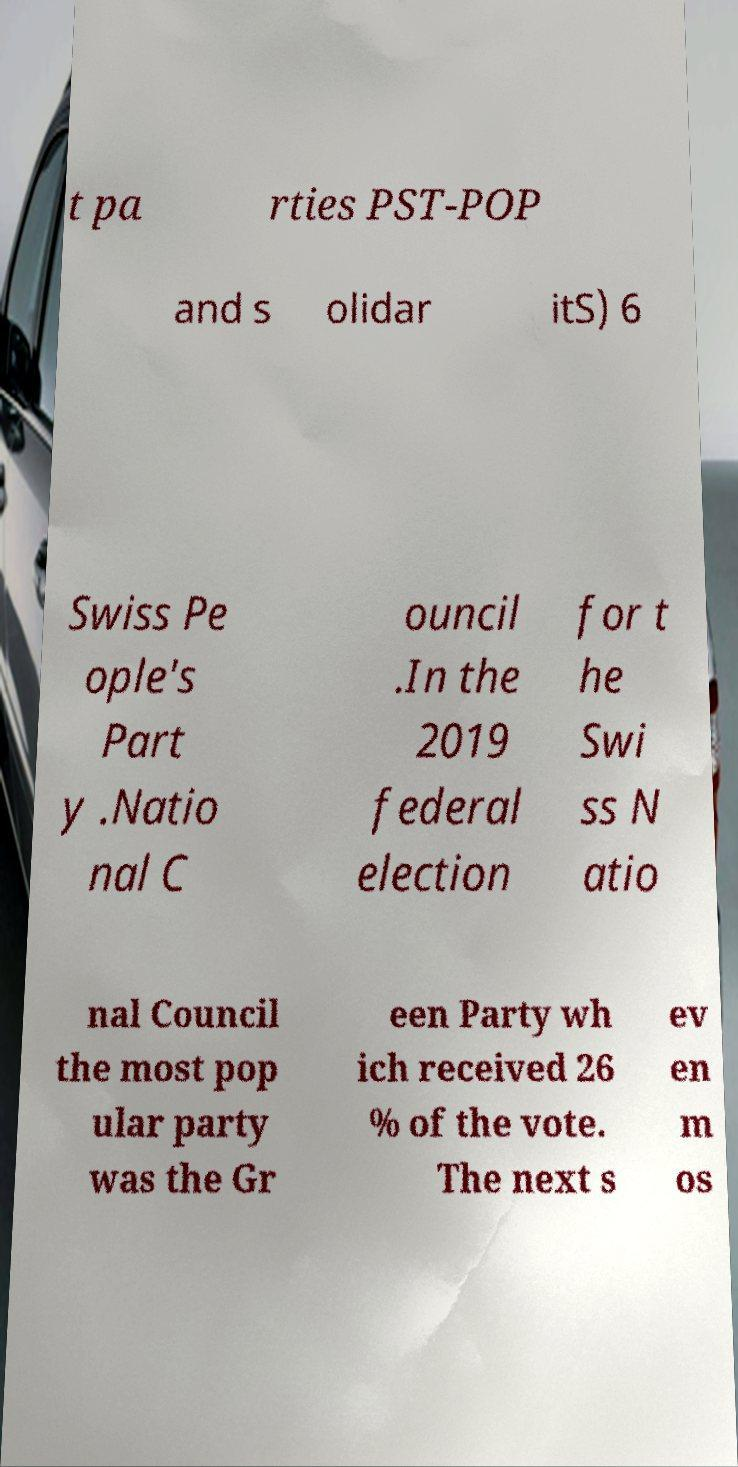I need the written content from this picture converted into text. Can you do that? t pa rties PST-POP and s olidar itS) 6 Swiss Pe ople's Part y .Natio nal C ouncil .In the 2019 federal election for t he Swi ss N atio nal Council the most pop ular party was the Gr een Party wh ich received 26 % of the vote. The next s ev en m os 